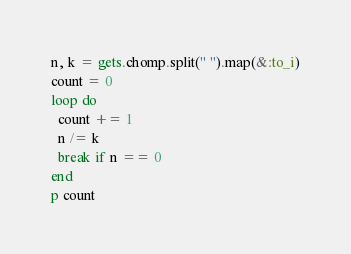Convert code to text. <code><loc_0><loc_0><loc_500><loc_500><_Ruby_>n, k = gets.chomp.split(" ").map(&:to_i)
count = 0
loop do
  count += 1
  n /= k
  break if n == 0
end
p count
</code> 